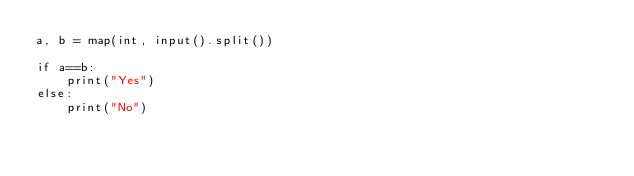Convert code to text. <code><loc_0><loc_0><loc_500><loc_500><_Python_>a, b = map(int, input().split())

if a==b:
    print("Yes")
else:
    print("No")</code> 